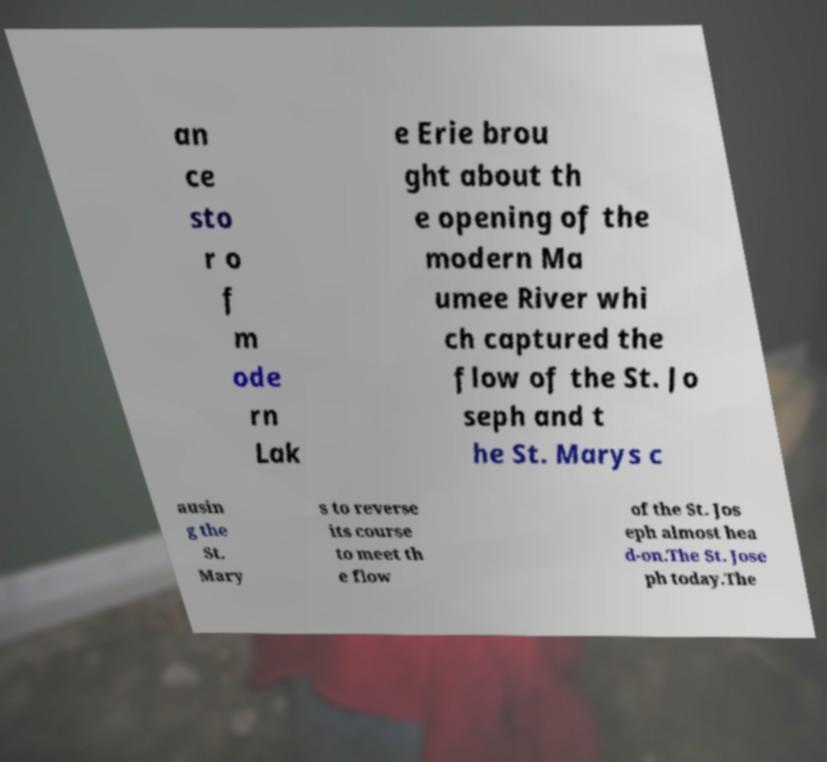Please read and relay the text visible in this image. What does it say? an ce sto r o f m ode rn Lak e Erie brou ght about th e opening of the modern Ma umee River whi ch captured the flow of the St. Jo seph and t he St. Marys c ausin g the St. Mary s to reverse its course to meet th e flow of the St. Jos eph almost hea d-on.The St. Jose ph today.The 